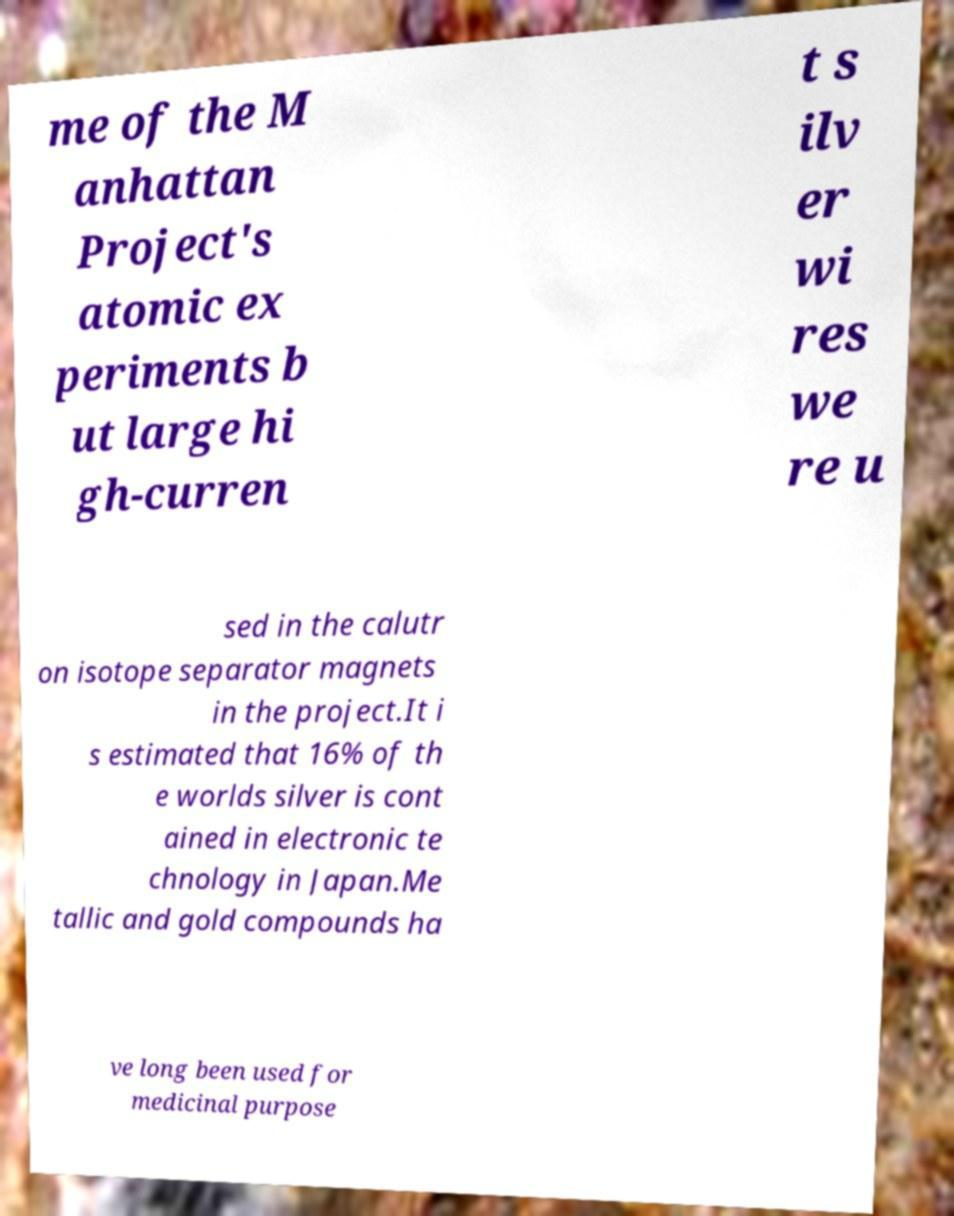Please identify and transcribe the text found in this image. me of the M anhattan Project's atomic ex periments b ut large hi gh-curren t s ilv er wi res we re u sed in the calutr on isotope separator magnets in the project.It i s estimated that 16% of th e worlds silver is cont ained in electronic te chnology in Japan.Me tallic and gold compounds ha ve long been used for medicinal purpose 